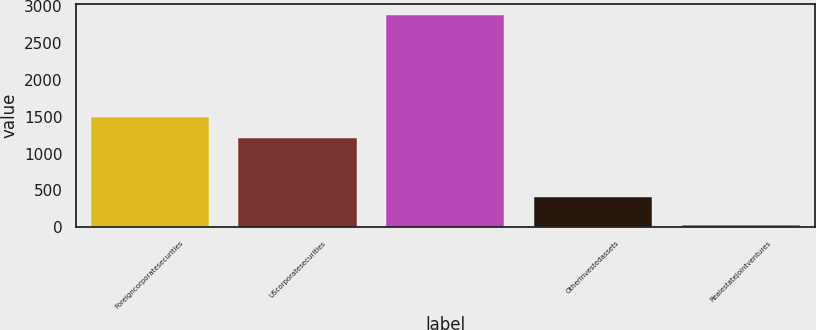Convert chart to OTSL. <chart><loc_0><loc_0><loc_500><loc_500><bar_chart><fcel>Foreigncorporatesecurities<fcel>UScorporatesecurities<fcel>Unnamed: 2<fcel>Otherinvestedassets<fcel>Realestatejointventures<nl><fcel>1501.7<fcel>1216<fcel>2887<fcel>409<fcel>30<nl></chart> 